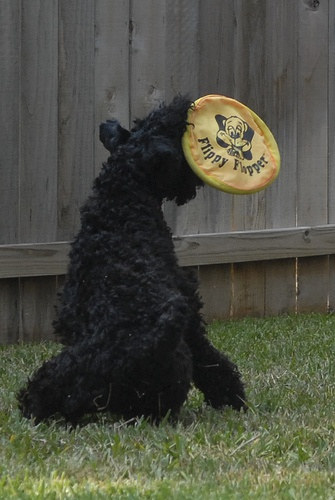Describe the objects in this image and their specific colors. I can see dog in gray, black, and darkgreen tones and frisbee in gray and tan tones in this image. 